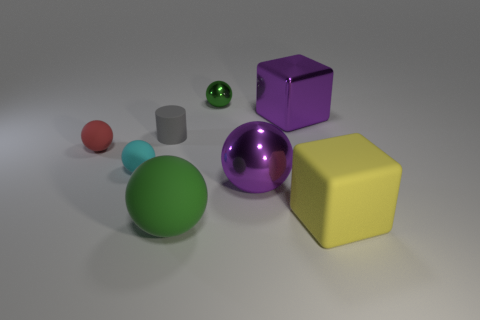Subtract all green rubber spheres. How many spheres are left? 4 Subtract all purple spheres. How many spheres are left? 4 Subtract all blue balls. Subtract all cyan cylinders. How many balls are left? 5 Subtract all blocks. How many objects are left? 6 Subtract all small metallic spheres. Subtract all big purple shiny cubes. How many objects are left? 6 Add 8 cyan balls. How many cyan balls are left? 9 Add 6 tiny shiny objects. How many tiny shiny objects exist? 7 Subtract 1 green balls. How many objects are left? 7 